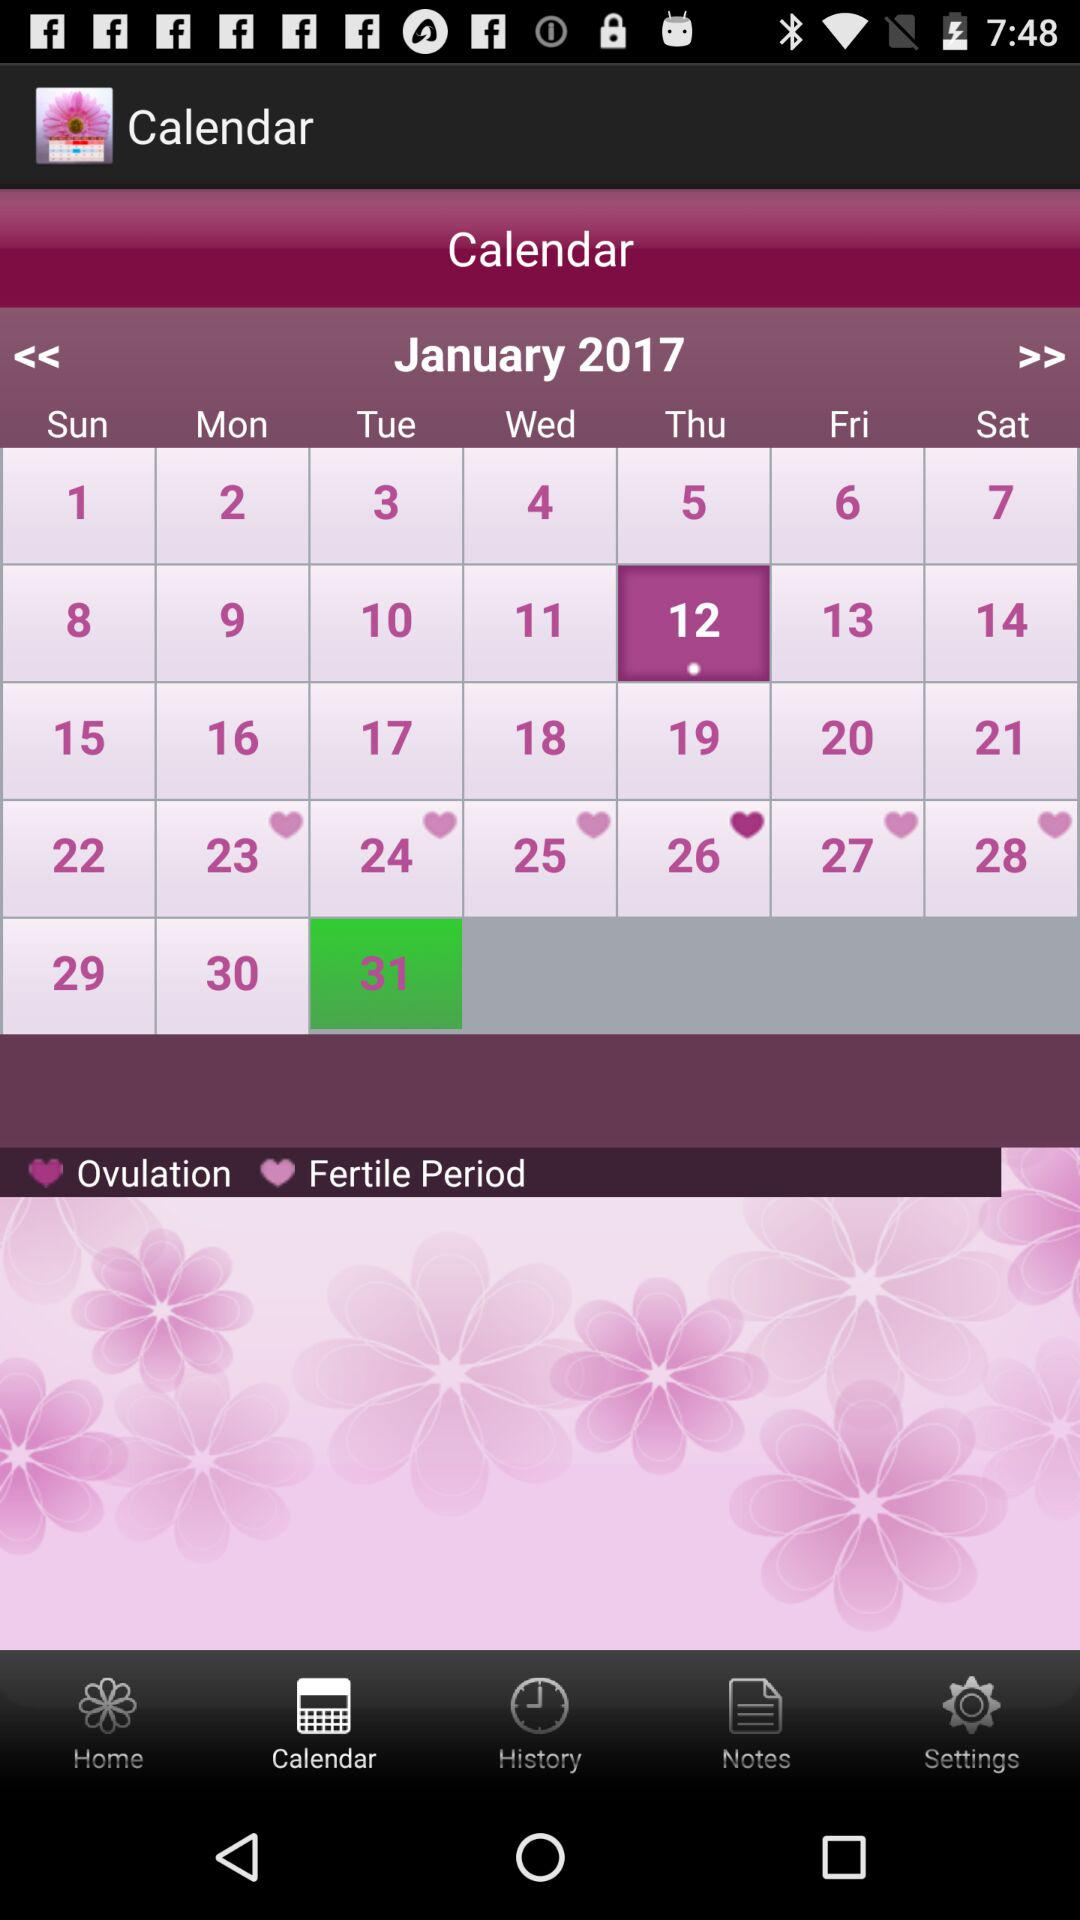What is the application name? The application name is "My Menstrual Diary". 